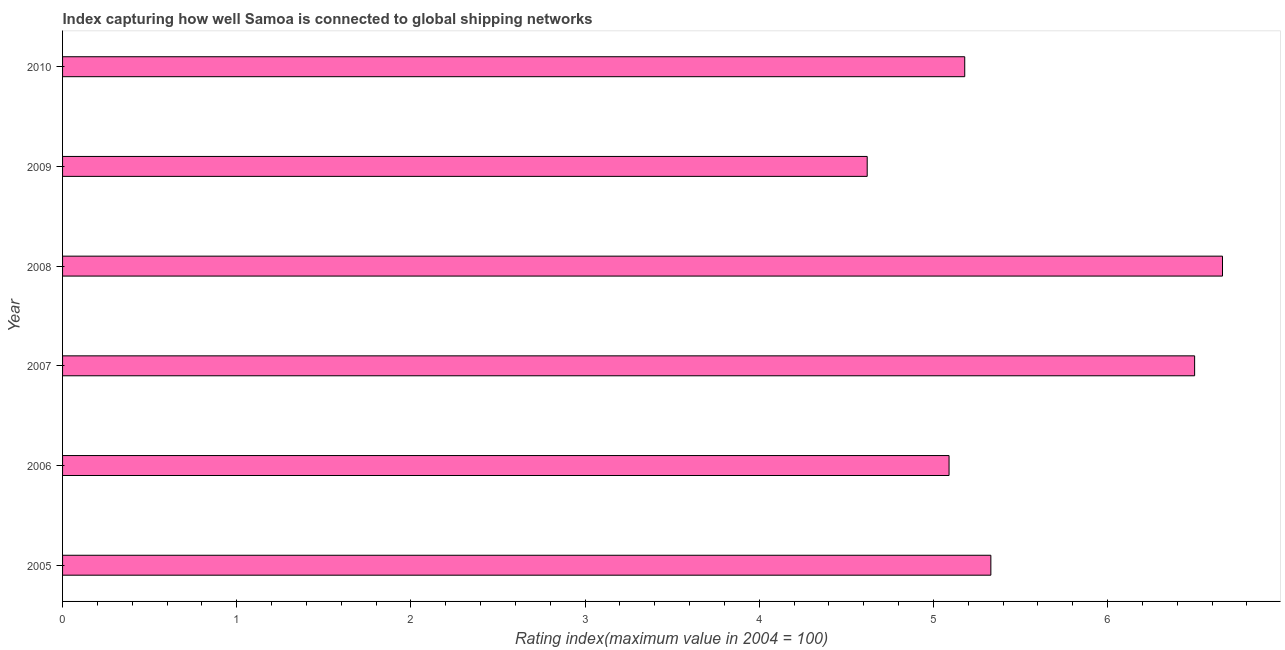Does the graph contain any zero values?
Provide a short and direct response. No. What is the title of the graph?
Offer a very short reply. Index capturing how well Samoa is connected to global shipping networks. What is the label or title of the X-axis?
Your response must be concise. Rating index(maximum value in 2004 = 100). What is the liner shipping connectivity index in 2006?
Offer a very short reply. 5.09. Across all years, what is the maximum liner shipping connectivity index?
Give a very brief answer. 6.66. Across all years, what is the minimum liner shipping connectivity index?
Ensure brevity in your answer.  4.62. In which year was the liner shipping connectivity index maximum?
Provide a succinct answer. 2008. In which year was the liner shipping connectivity index minimum?
Provide a succinct answer. 2009. What is the sum of the liner shipping connectivity index?
Your answer should be very brief. 33.38. What is the difference between the liner shipping connectivity index in 2007 and 2008?
Give a very brief answer. -0.16. What is the average liner shipping connectivity index per year?
Your answer should be very brief. 5.56. What is the median liner shipping connectivity index?
Make the answer very short. 5.25. Is the liner shipping connectivity index in 2006 less than that in 2008?
Provide a succinct answer. Yes. Is the difference between the liner shipping connectivity index in 2006 and 2007 greater than the difference between any two years?
Your answer should be compact. No. What is the difference between the highest and the second highest liner shipping connectivity index?
Provide a succinct answer. 0.16. What is the difference between the highest and the lowest liner shipping connectivity index?
Keep it short and to the point. 2.04. In how many years, is the liner shipping connectivity index greater than the average liner shipping connectivity index taken over all years?
Your answer should be compact. 2. How many years are there in the graph?
Provide a short and direct response. 6. Are the values on the major ticks of X-axis written in scientific E-notation?
Your answer should be very brief. No. What is the Rating index(maximum value in 2004 = 100) of 2005?
Offer a terse response. 5.33. What is the Rating index(maximum value in 2004 = 100) of 2006?
Provide a succinct answer. 5.09. What is the Rating index(maximum value in 2004 = 100) of 2008?
Make the answer very short. 6.66. What is the Rating index(maximum value in 2004 = 100) of 2009?
Ensure brevity in your answer.  4.62. What is the Rating index(maximum value in 2004 = 100) in 2010?
Provide a succinct answer. 5.18. What is the difference between the Rating index(maximum value in 2004 = 100) in 2005 and 2006?
Offer a terse response. 0.24. What is the difference between the Rating index(maximum value in 2004 = 100) in 2005 and 2007?
Your answer should be very brief. -1.17. What is the difference between the Rating index(maximum value in 2004 = 100) in 2005 and 2008?
Offer a terse response. -1.33. What is the difference between the Rating index(maximum value in 2004 = 100) in 2005 and 2009?
Provide a short and direct response. 0.71. What is the difference between the Rating index(maximum value in 2004 = 100) in 2005 and 2010?
Your answer should be very brief. 0.15. What is the difference between the Rating index(maximum value in 2004 = 100) in 2006 and 2007?
Keep it short and to the point. -1.41. What is the difference between the Rating index(maximum value in 2004 = 100) in 2006 and 2008?
Give a very brief answer. -1.57. What is the difference between the Rating index(maximum value in 2004 = 100) in 2006 and 2009?
Your response must be concise. 0.47. What is the difference between the Rating index(maximum value in 2004 = 100) in 2006 and 2010?
Provide a succinct answer. -0.09. What is the difference between the Rating index(maximum value in 2004 = 100) in 2007 and 2008?
Make the answer very short. -0.16. What is the difference between the Rating index(maximum value in 2004 = 100) in 2007 and 2009?
Keep it short and to the point. 1.88. What is the difference between the Rating index(maximum value in 2004 = 100) in 2007 and 2010?
Give a very brief answer. 1.32. What is the difference between the Rating index(maximum value in 2004 = 100) in 2008 and 2009?
Your answer should be very brief. 2.04. What is the difference between the Rating index(maximum value in 2004 = 100) in 2008 and 2010?
Offer a very short reply. 1.48. What is the difference between the Rating index(maximum value in 2004 = 100) in 2009 and 2010?
Provide a short and direct response. -0.56. What is the ratio of the Rating index(maximum value in 2004 = 100) in 2005 to that in 2006?
Your answer should be compact. 1.05. What is the ratio of the Rating index(maximum value in 2004 = 100) in 2005 to that in 2007?
Your answer should be compact. 0.82. What is the ratio of the Rating index(maximum value in 2004 = 100) in 2005 to that in 2009?
Make the answer very short. 1.15. What is the ratio of the Rating index(maximum value in 2004 = 100) in 2005 to that in 2010?
Provide a short and direct response. 1.03. What is the ratio of the Rating index(maximum value in 2004 = 100) in 2006 to that in 2007?
Your answer should be compact. 0.78. What is the ratio of the Rating index(maximum value in 2004 = 100) in 2006 to that in 2008?
Give a very brief answer. 0.76. What is the ratio of the Rating index(maximum value in 2004 = 100) in 2006 to that in 2009?
Ensure brevity in your answer.  1.1. What is the ratio of the Rating index(maximum value in 2004 = 100) in 2006 to that in 2010?
Keep it short and to the point. 0.98. What is the ratio of the Rating index(maximum value in 2004 = 100) in 2007 to that in 2008?
Your response must be concise. 0.98. What is the ratio of the Rating index(maximum value in 2004 = 100) in 2007 to that in 2009?
Your answer should be very brief. 1.41. What is the ratio of the Rating index(maximum value in 2004 = 100) in 2007 to that in 2010?
Offer a very short reply. 1.25. What is the ratio of the Rating index(maximum value in 2004 = 100) in 2008 to that in 2009?
Keep it short and to the point. 1.44. What is the ratio of the Rating index(maximum value in 2004 = 100) in 2008 to that in 2010?
Your answer should be compact. 1.29. What is the ratio of the Rating index(maximum value in 2004 = 100) in 2009 to that in 2010?
Provide a succinct answer. 0.89. 